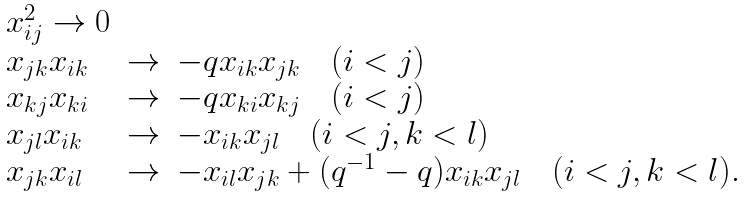Convert formula to latex. <formula><loc_0><loc_0><loc_500><loc_500>\begin{array} { l c l } x _ { i j } ^ { 2 } \rightarrow 0 \\ x _ { j k } x _ { i k } & \rightarrow & - q x _ { i k } x _ { j k } \quad ( i < j ) \\ x _ { k j } x _ { k i } & \rightarrow & - q x _ { k i } x _ { k j } \quad ( i < j ) \\ x _ { j l } x _ { i k } & \rightarrow & - x _ { i k } x _ { j l } \quad ( i < j , k < l ) \\ x _ { j k } x _ { i l } & \rightarrow & - x _ { i l } x _ { j k } + ( q ^ { - 1 } - q ) x _ { i k } x _ { j l } \quad ( i < j , k < l ) . \end{array}</formula> 